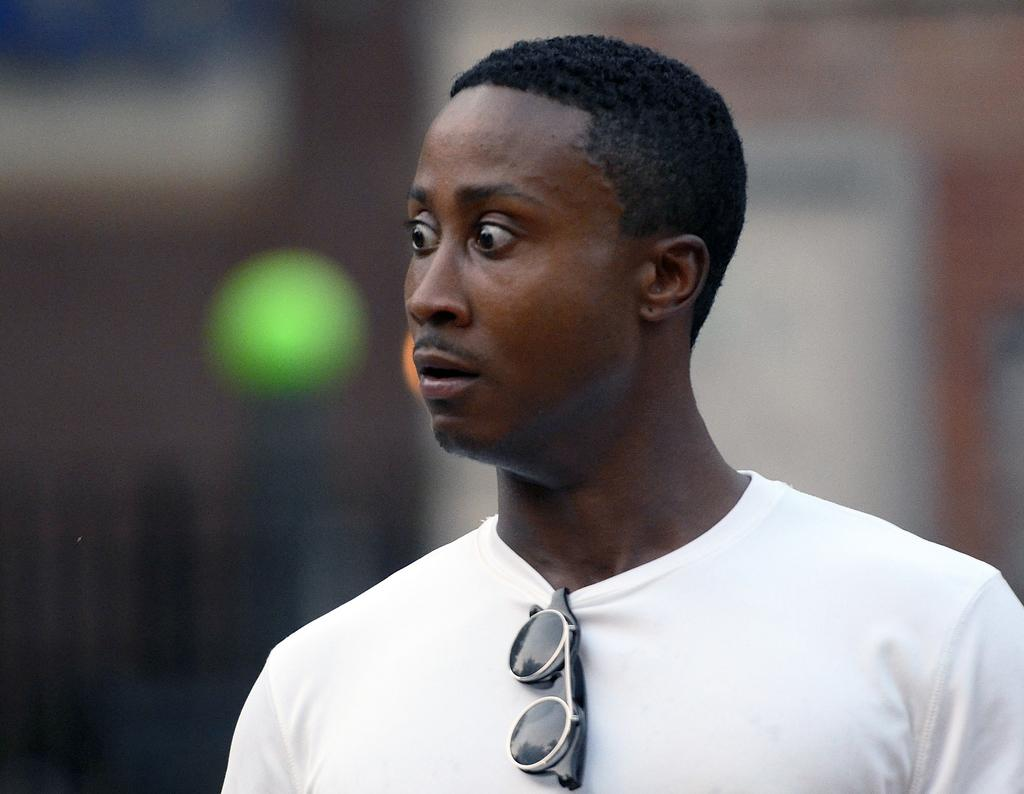What is the main subject of the image? There is a person in the image. What is depicted on the person's t-shirt? The person's t-shirt has sunglasses on it. Can you describe the background of the image? The background of the image is blurred. How many cannons are visible in the image? There are no cannons present in the image. What type of card is the person holding in the image? There is no card present in the image. 